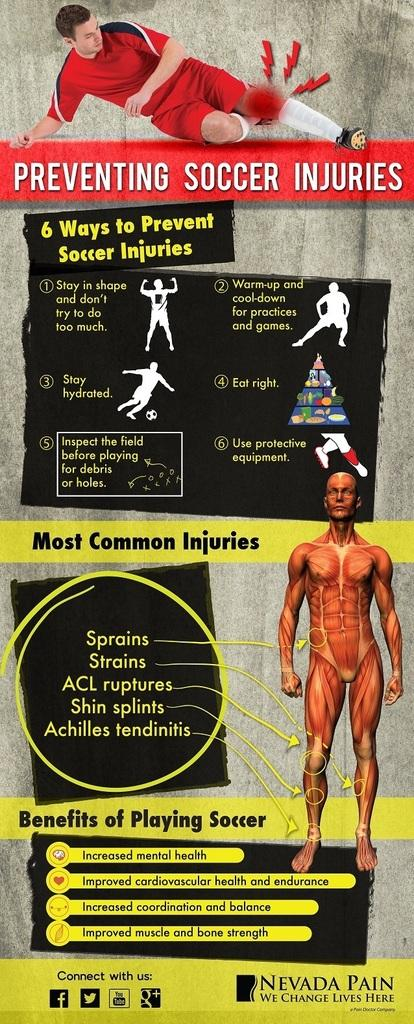What is featured on the poster in the image? There is a poster in the image that contains text and a picture of a man. What is the man in the picture wearing? The man in the picture is wearing a red dress. What is the name of the base that the man is standing on in the image? There is no base present in the image, and the man is not standing on anything. 